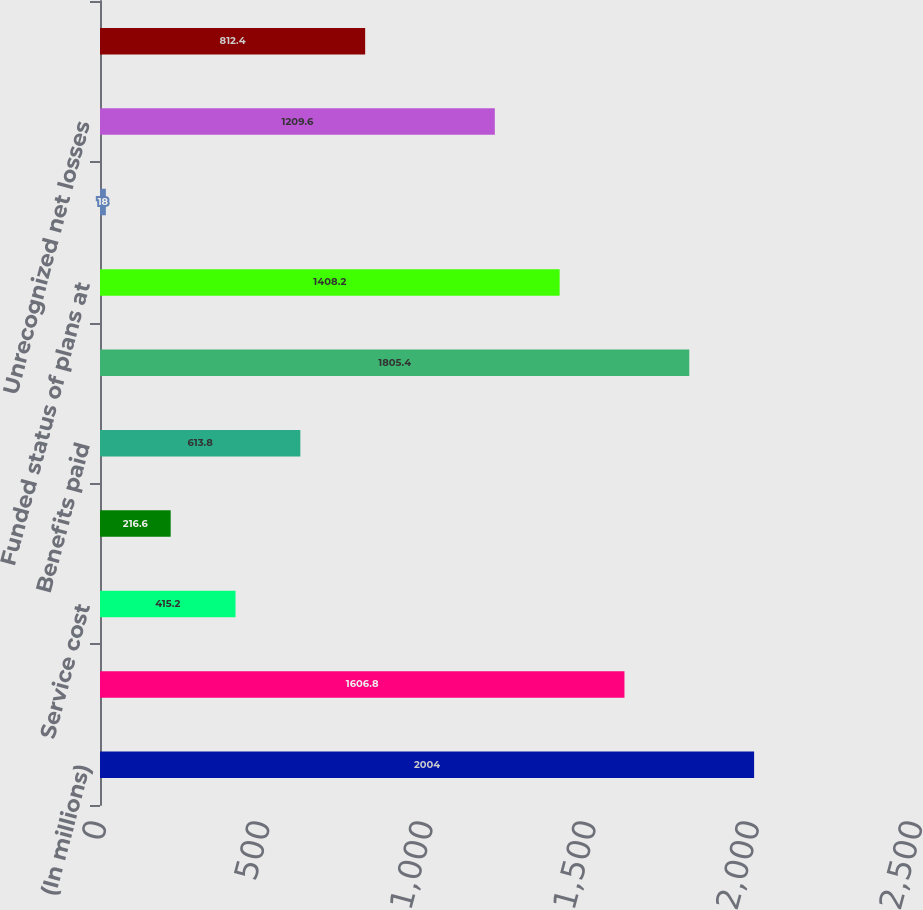Convert chart to OTSL. <chart><loc_0><loc_0><loc_500><loc_500><bar_chart><fcel>(In millions)<fcel>Benefit obligations at January<fcel>Service cost<fcel>Interest cost<fcel>Benefits paid<fcel>Benefit obligations at<fcel>Funded status of plans at<fcel>Unrecognized prior service<fcel>Unrecognized net losses<fcel>Accrued benefit cost<nl><fcel>2004<fcel>1606.8<fcel>415.2<fcel>216.6<fcel>613.8<fcel>1805.4<fcel>1408.2<fcel>18<fcel>1209.6<fcel>812.4<nl></chart> 